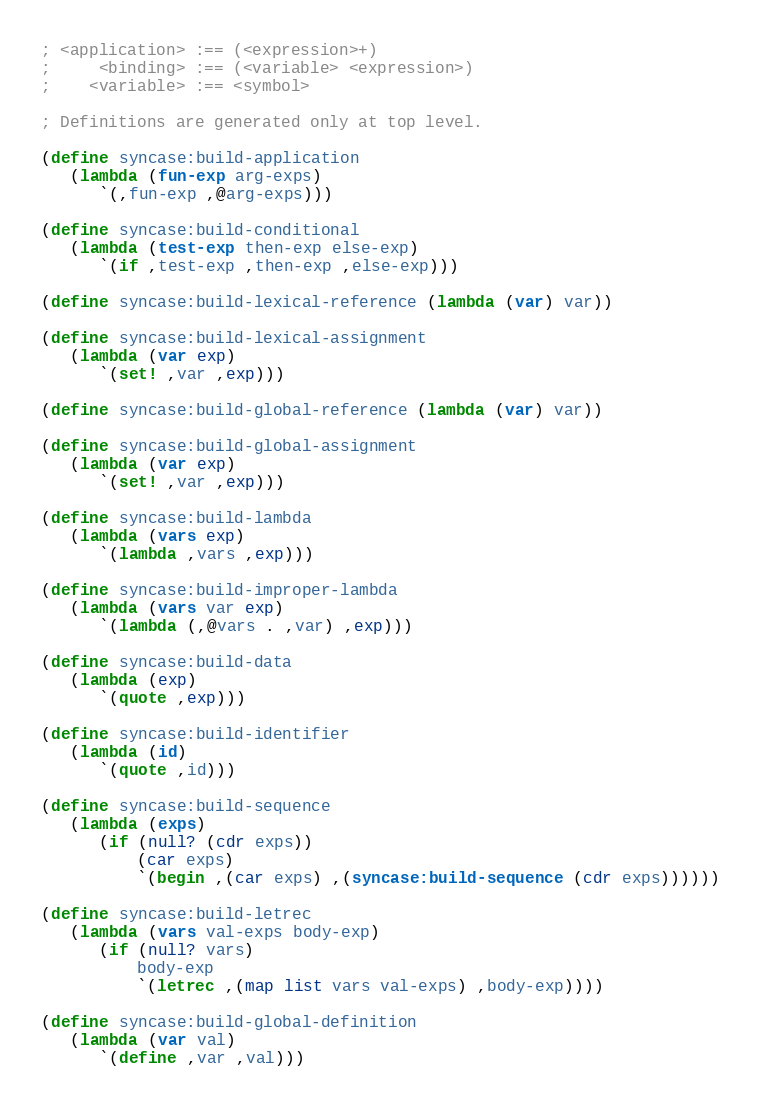Convert code to text. <code><loc_0><loc_0><loc_500><loc_500><_Scheme_>; <application> :== (<expression>+)
;     <binding> :== (<variable> <expression>)
;    <variable> :== <symbol>

; Definitions are generated only at top level.

(define syncase:build-application
   (lambda (fun-exp arg-exps)
      `(,fun-exp ,@arg-exps)))

(define syncase:build-conditional
   (lambda (test-exp then-exp else-exp)
      `(if ,test-exp ,then-exp ,else-exp)))

(define syncase:build-lexical-reference (lambda (var) var))

(define syncase:build-lexical-assignment
   (lambda (var exp)
      `(set! ,var ,exp)))

(define syncase:build-global-reference (lambda (var) var))

(define syncase:build-global-assignment
   (lambda (var exp)
      `(set! ,var ,exp)))

(define syncase:build-lambda
   (lambda (vars exp)
      `(lambda ,vars ,exp)))

(define syncase:build-improper-lambda
   (lambda (vars var exp)
      `(lambda (,@vars . ,var) ,exp)))

(define syncase:build-data
   (lambda (exp)
      `(quote ,exp)))

(define syncase:build-identifier
   (lambda (id)
      `(quote ,id)))

(define syncase:build-sequence
   (lambda (exps)
      (if (null? (cdr exps))
          (car exps)
          `(begin ,(car exps) ,(syncase:build-sequence (cdr exps))))))

(define syncase:build-letrec
   (lambda (vars val-exps body-exp)
      (if (null? vars)
          body-exp
          `(letrec ,(map list vars val-exps) ,body-exp))))

(define syncase:build-global-definition
   (lambda (var val)
      `(define ,var ,val)))
</code> 